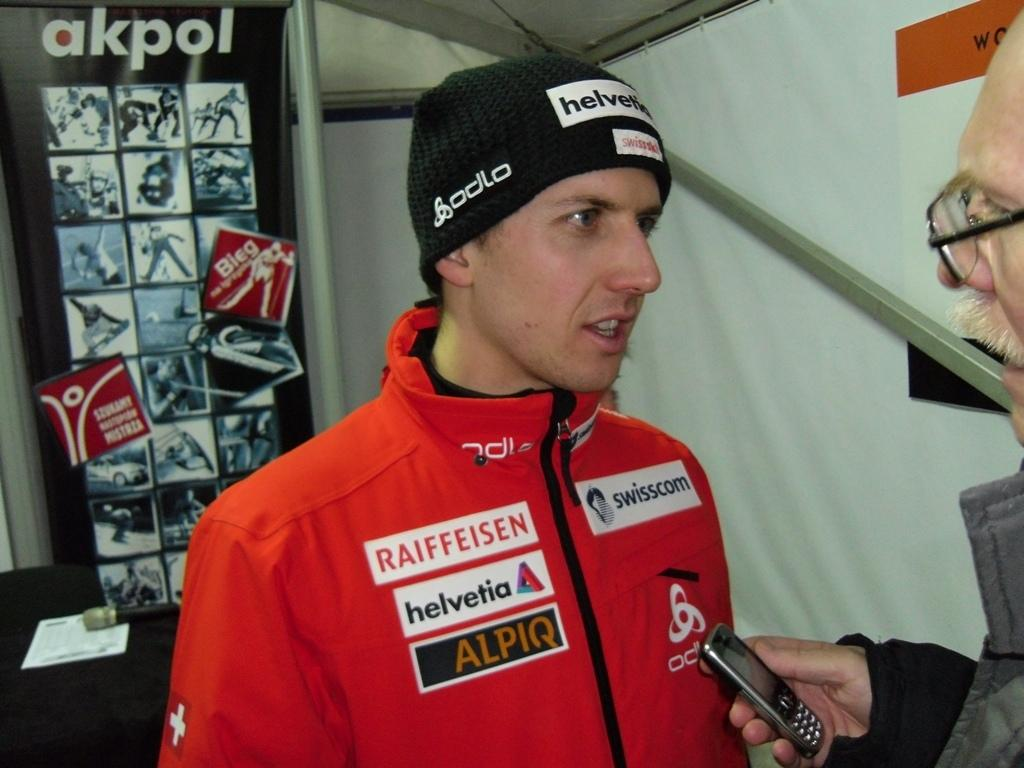<image>
Share a concise interpretation of the image provided. A man with a jacket that says Raiffeisen talks to someone holding a phone 